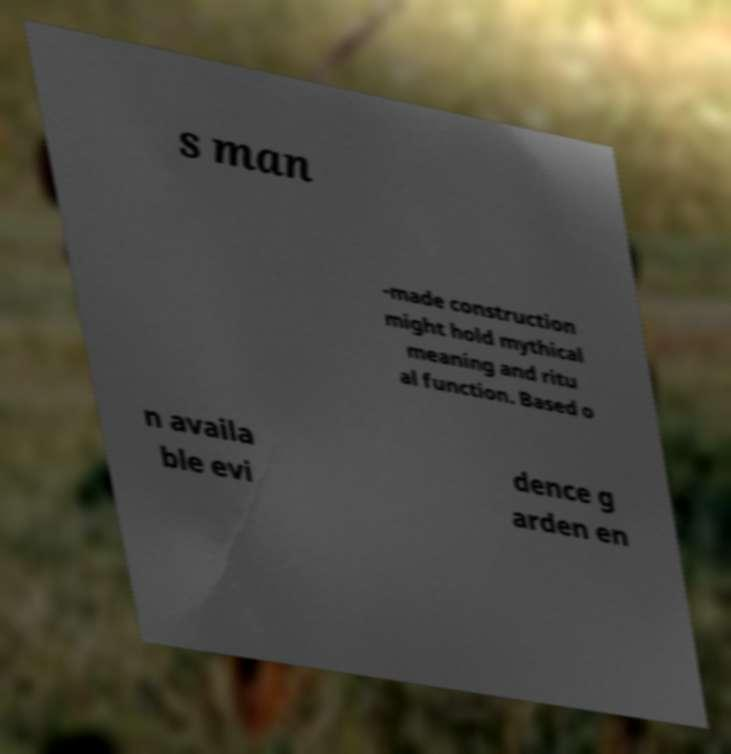Can you read and provide the text displayed in the image?This photo seems to have some interesting text. Can you extract and type it out for me? s man -made construction might hold mythical meaning and ritu al function. Based o n availa ble evi dence g arden en 